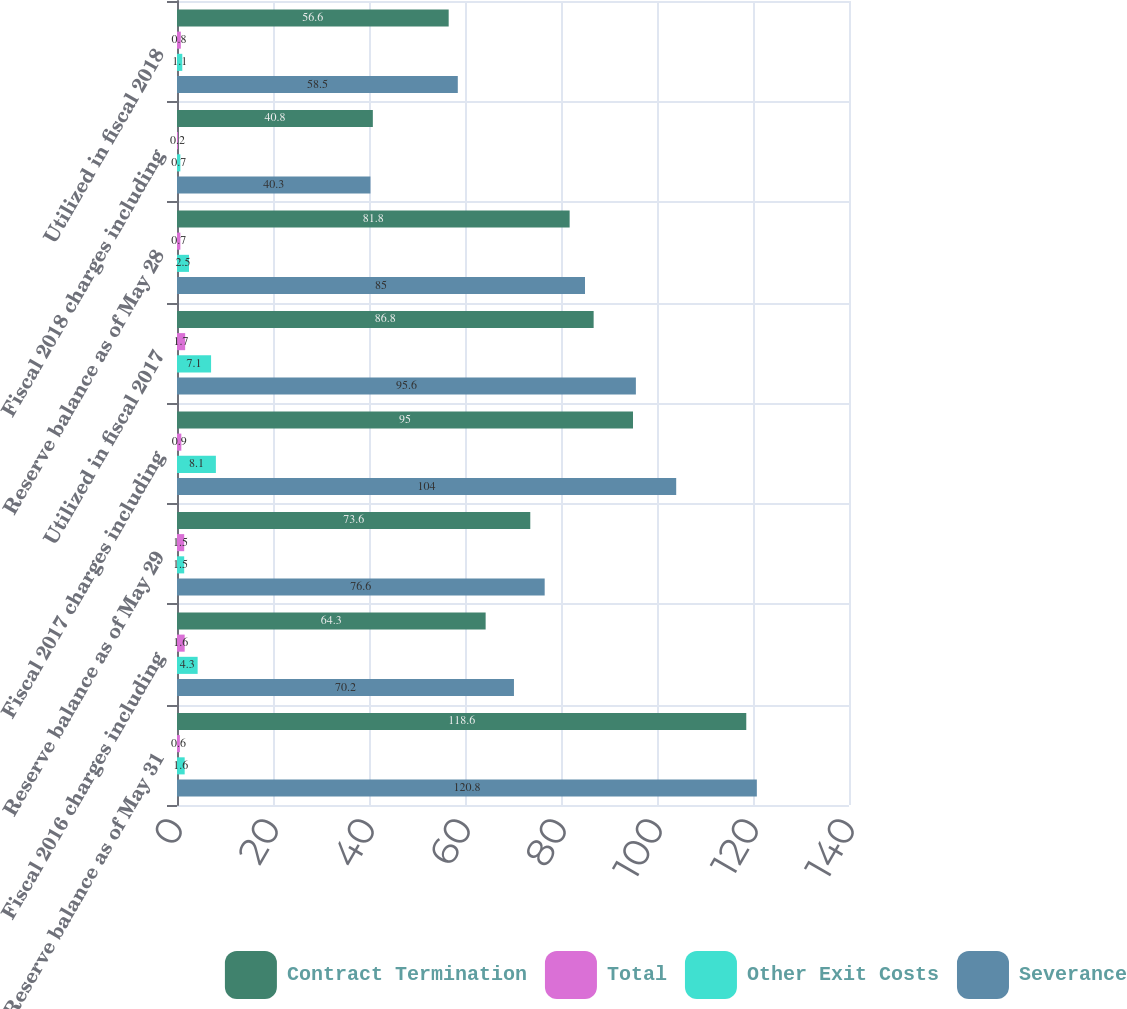Convert chart. <chart><loc_0><loc_0><loc_500><loc_500><stacked_bar_chart><ecel><fcel>Reserve balance as of May 31<fcel>Fiscal 2016 charges including<fcel>Reserve balance as of May 29<fcel>Fiscal 2017 charges including<fcel>Utilized in fiscal 2017<fcel>Reserve balance as of May 28<fcel>Fiscal 2018 charges including<fcel>Utilized in fiscal 2018<nl><fcel>Contract Termination<fcel>118.6<fcel>64.3<fcel>73.6<fcel>95<fcel>86.8<fcel>81.8<fcel>40.8<fcel>56.6<nl><fcel>Total<fcel>0.6<fcel>1.6<fcel>1.5<fcel>0.9<fcel>1.7<fcel>0.7<fcel>0.2<fcel>0.8<nl><fcel>Other Exit Costs<fcel>1.6<fcel>4.3<fcel>1.5<fcel>8.1<fcel>7.1<fcel>2.5<fcel>0.7<fcel>1.1<nl><fcel>Severance<fcel>120.8<fcel>70.2<fcel>76.6<fcel>104<fcel>95.6<fcel>85<fcel>40.3<fcel>58.5<nl></chart> 